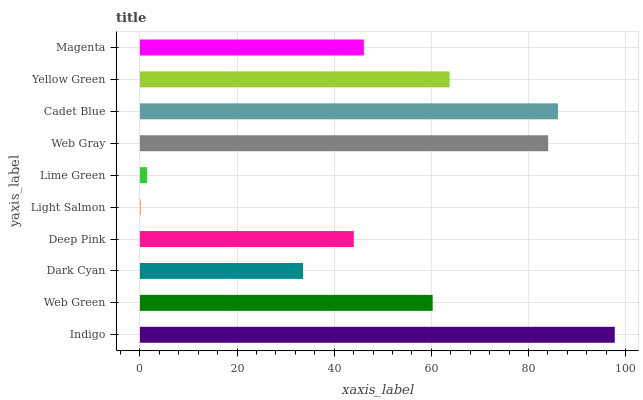Is Light Salmon the minimum?
Answer yes or no. Yes. Is Indigo the maximum?
Answer yes or no. Yes. Is Web Green the minimum?
Answer yes or no. No. Is Web Green the maximum?
Answer yes or no. No. Is Indigo greater than Web Green?
Answer yes or no. Yes. Is Web Green less than Indigo?
Answer yes or no. Yes. Is Web Green greater than Indigo?
Answer yes or no. No. Is Indigo less than Web Green?
Answer yes or no. No. Is Web Green the high median?
Answer yes or no. Yes. Is Magenta the low median?
Answer yes or no. Yes. Is Web Gray the high median?
Answer yes or no. No. Is Light Salmon the low median?
Answer yes or no. No. 